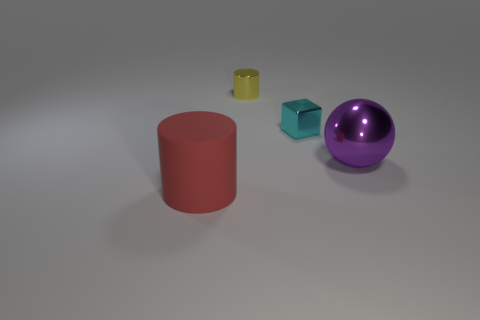How many other objects are the same color as the metallic ball?
Provide a succinct answer. 0. Is the large thing on the right side of the big red cylinder made of the same material as the tiny cylinder?
Your answer should be compact. Yes. Is the number of big balls that are on the left side of the small yellow cylinder less than the number of tiny objects that are to the right of the large purple shiny object?
Provide a succinct answer. No. What number of other objects are there of the same material as the yellow object?
Offer a very short reply. 2. There is a yellow thing that is the same size as the cyan shiny block; what is its material?
Keep it short and to the point. Metal. Are there fewer rubber cylinders that are on the right side of the tiny cube than purple spheres?
Provide a short and direct response. Yes. There is a large thing left of the cylinder behind the cylinder in front of the large purple thing; what shape is it?
Your answer should be very brief. Cylinder. What size is the cylinder that is on the right side of the red thing?
Your response must be concise. Small. What is the shape of the thing that is the same size as the cyan block?
Provide a succinct answer. Cylinder. How many objects are large shiny balls or small metal things to the right of the yellow cylinder?
Ensure brevity in your answer.  2. 